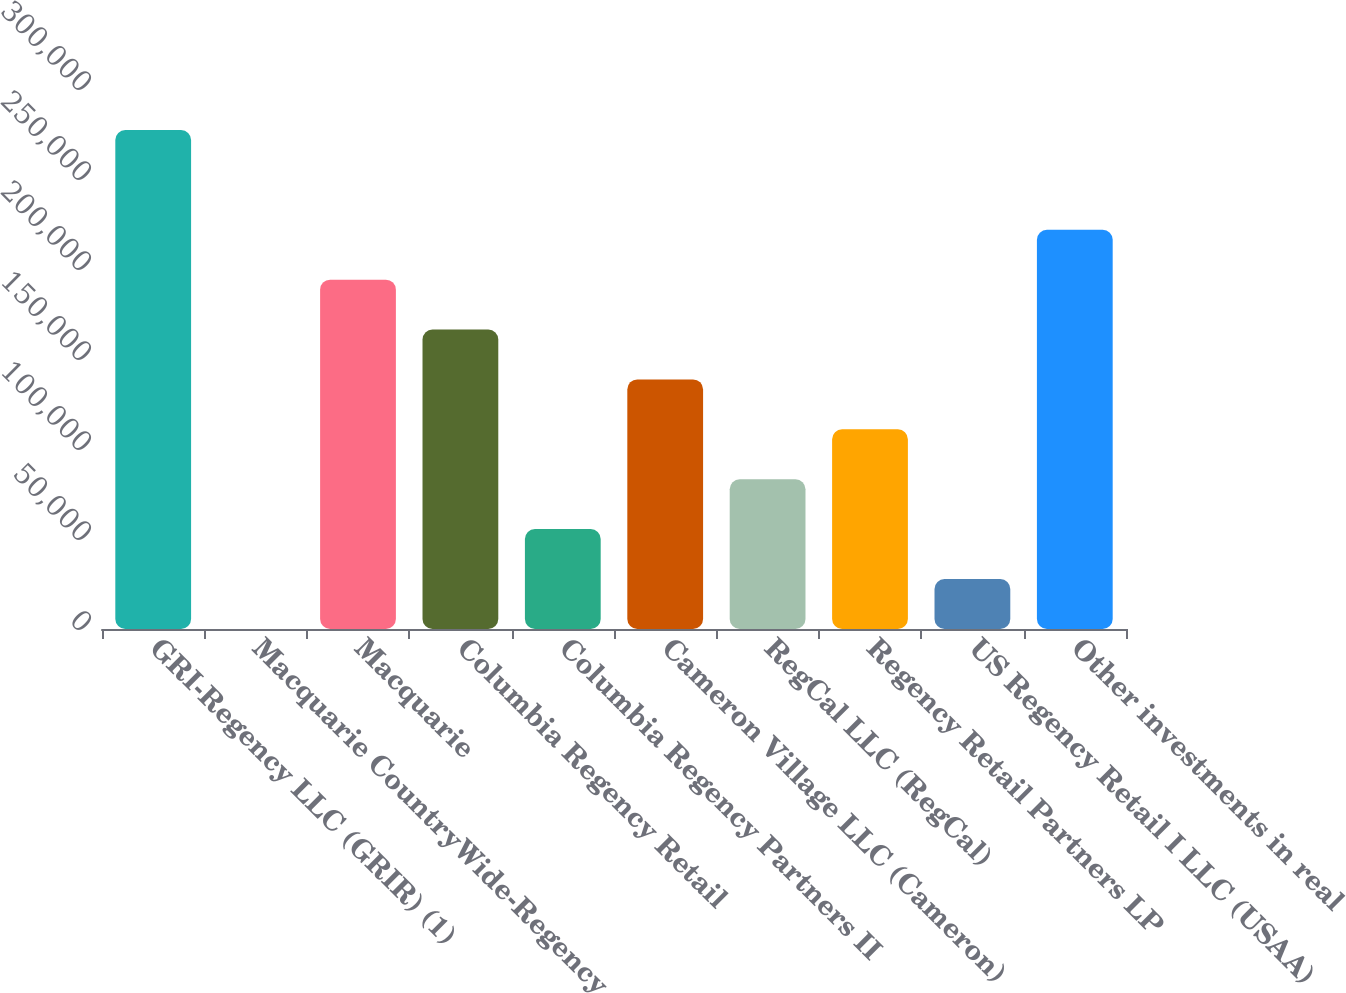<chart> <loc_0><loc_0><loc_500><loc_500><bar_chart><fcel>GRI-Regency LLC (GRIR) (1)<fcel>Macquarie CountryWide-Regency<fcel>Macquarie<fcel>Columbia Regency Retail<fcel>Columbia Regency Partners II<fcel>Cameron Village LLC (Cameron)<fcel>RegCal LLC (RegCal)<fcel>Regency Retail Partners LP<fcel>US Regency Retail I LLC (USAA)<fcel>Other investments in real<nl><fcel>277235<fcel>63<fcel>194083<fcel>166366<fcel>55497.4<fcel>138649<fcel>83214.6<fcel>110932<fcel>27780.2<fcel>221801<nl></chart> 